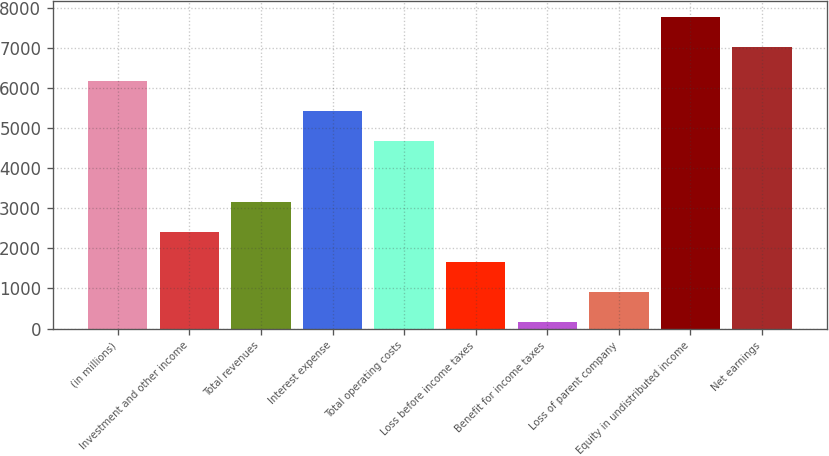Convert chart to OTSL. <chart><loc_0><loc_0><loc_500><loc_500><bar_chart><fcel>(in millions)<fcel>Investment and other income<fcel>Total revenues<fcel>Interest expense<fcel>Total operating costs<fcel>Loss before income taxes<fcel>Benefit for income taxes<fcel>Loss of parent company<fcel>Equity in undistributed income<fcel>Net earnings<nl><fcel>6169<fcel>2416.5<fcel>3167<fcel>5418.5<fcel>4668<fcel>1666<fcel>165<fcel>915.5<fcel>7767.5<fcel>7017<nl></chart> 